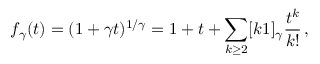Convert formula to latex. <formula><loc_0><loc_0><loc_500><loc_500>f _ { \gamma } ( t ) = ( 1 + \gamma t ) ^ { 1 / \gamma } = 1 + t + \sum _ { k \geq 2 } [ k 1 ] _ { \gamma } \frac { t ^ { k } } { k ! } \, ,</formula> 